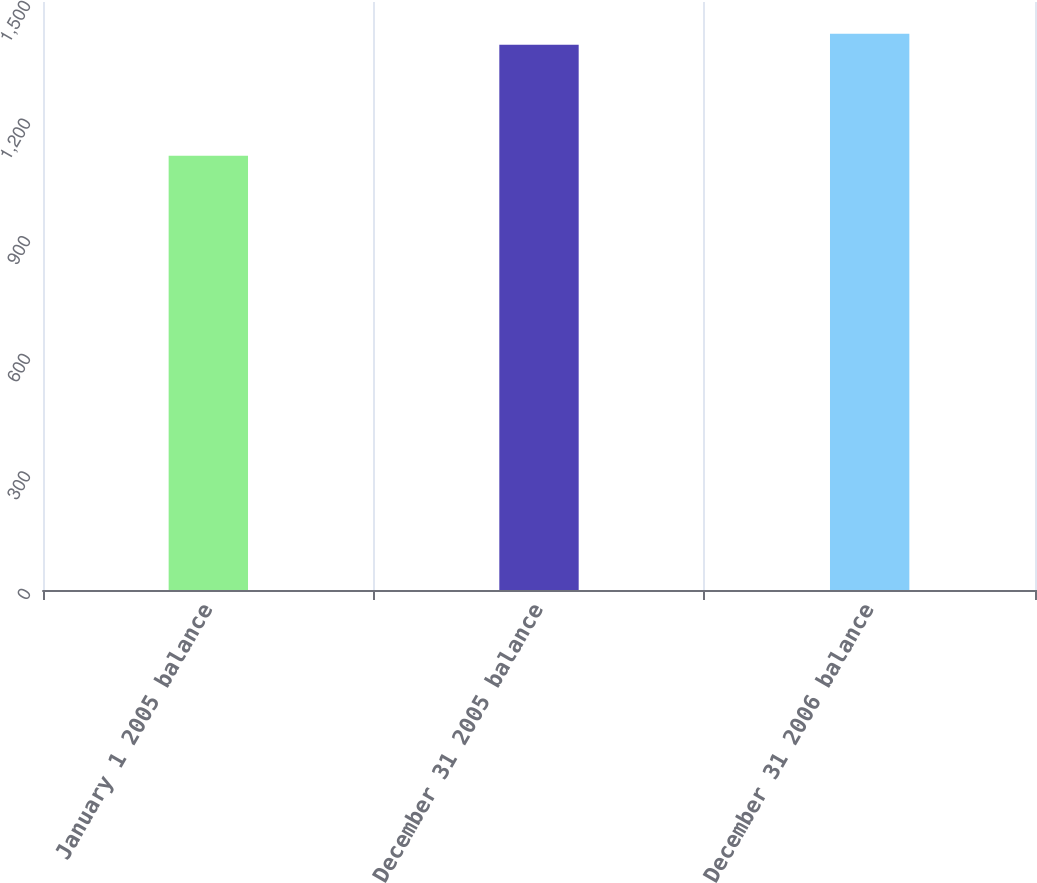Convert chart. <chart><loc_0><loc_0><loc_500><loc_500><bar_chart><fcel>January 1 2005 balance<fcel>December 31 2005 balance<fcel>December 31 2006 balance<nl><fcel>1107.6<fcel>1390.7<fcel>1419.14<nl></chart> 